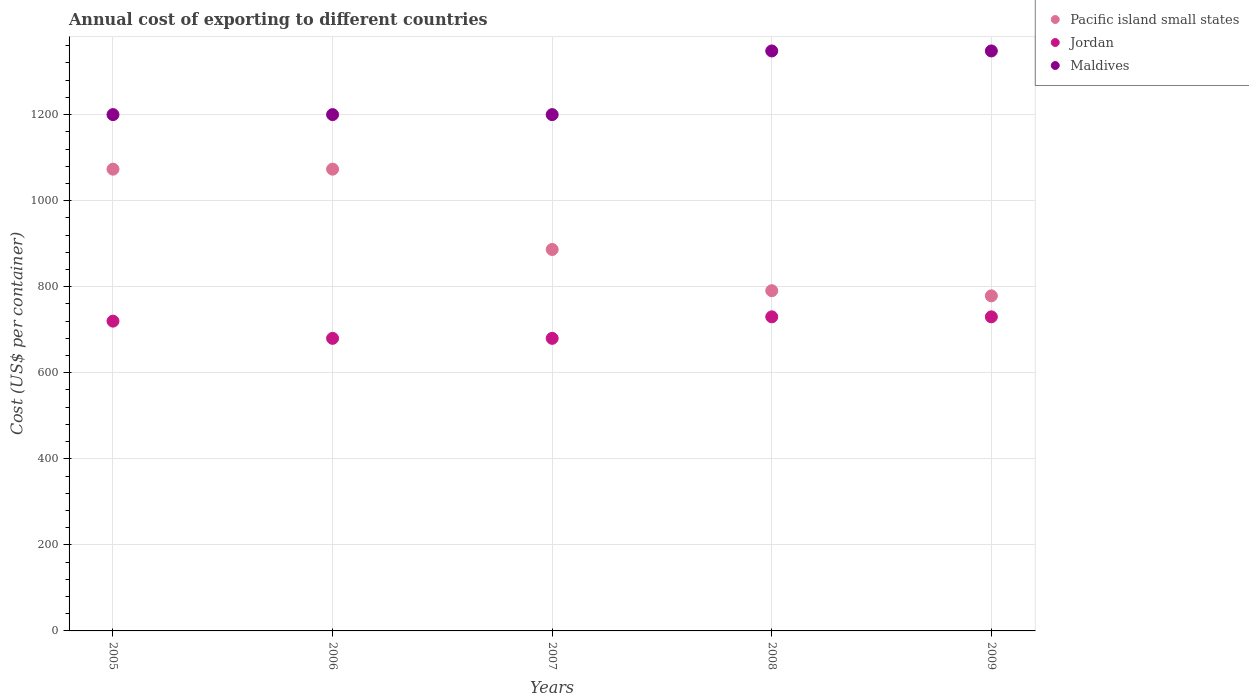What is the total annual cost of exporting in Pacific island small states in 2006?
Offer a terse response. 1073.22. Across all years, what is the maximum total annual cost of exporting in Maldives?
Offer a very short reply. 1348. Across all years, what is the minimum total annual cost of exporting in Pacific island small states?
Offer a terse response. 778.78. What is the total total annual cost of exporting in Maldives in the graph?
Provide a short and direct response. 6296. What is the difference between the total annual cost of exporting in Pacific island small states in 2007 and that in 2009?
Make the answer very short. 107.78. What is the difference between the total annual cost of exporting in Jordan in 2006 and the total annual cost of exporting in Pacific island small states in 2008?
Your answer should be compact. -110.78. What is the average total annual cost of exporting in Jordan per year?
Give a very brief answer. 708. In the year 2005, what is the difference between the total annual cost of exporting in Maldives and total annual cost of exporting in Pacific island small states?
Make the answer very short. 126.78. In how many years, is the total annual cost of exporting in Maldives greater than 880 US$?
Offer a terse response. 5. What is the ratio of the total annual cost of exporting in Maldives in 2005 to that in 2007?
Provide a succinct answer. 1. Is the total annual cost of exporting in Pacific island small states in 2005 less than that in 2007?
Offer a terse response. No. What is the difference between the highest and the second highest total annual cost of exporting in Pacific island small states?
Give a very brief answer. 0. What is the difference between the highest and the lowest total annual cost of exporting in Pacific island small states?
Your answer should be very brief. 294.44. Does the total annual cost of exporting in Maldives monotonically increase over the years?
Offer a terse response. No. Is the total annual cost of exporting in Jordan strictly less than the total annual cost of exporting in Maldives over the years?
Your response must be concise. Yes. How many dotlines are there?
Provide a succinct answer. 3. What is the difference between two consecutive major ticks on the Y-axis?
Provide a short and direct response. 200. Does the graph contain any zero values?
Provide a short and direct response. No. Does the graph contain grids?
Make the answer very short. Yes. Where does the legend appear in the graph?
Make the answer very short. Top right. How are the legend labels stacked?
Ensure brevity in your answer.  Vertical. What is the title of the graph?
Your answer should be very brief. Annual cost of exporting to different countries. Does "Ireland" appear as one of the legend labels in the graph?
Keep it short and to the point. No. What is the label or title of the Y-axis?
Offer a terse response. Cost (US$ per container). What is the Cost (US$ per container) of Pacific island small states in 2005?
Your response must be concise. 1073.22. What is the Cost (US$ per container) of Jordan in 2005?
Your answer should be very brief. 720. What is the Cost (US$ per container) of Maldives in 2005?
Provide a short and direct response. 1200. What is the Cost (US$ per container) of Pacific island small states in 2006?
Offer a terse response. 1073.22. What is the Cost (US$ per container) in Jordan in 2006?
Your answer should be very brief. 680. What is the Cost (US$ per container) of Maldives in 2006?
Keep it short and to the point. 1200. What is the Cost (US$ per container) in Pacific island small states in 2007?
Offer a terse response. 886.56. What is the Cost (US$ per container) of Jordan in 2007?
Offer a terse response. 680. What is the Cost (US$ per container) of Maldives in 2007?
Ensure brevity in your answer.  1200. What is the Cost (US$ per container) of Pacific island small states in 2008?
Offer a terse response. 790.78. What is the Cost (US$ per container) of Jordan in 2008?
Make the answer very short. 730. What is the Cost (US$ per container) of Maldives in 2008?
Give a very brief answer. 1348. What is the Cost (US$ per container) in Pacific island small states in 2009?
Provide a succinct answer. 778.78. What is the Cost (US$ per container) of Jordan in 2009?
Provide a succinct answer. 730. What is the Cost (US$ per container) of Maldives in 2009?
Provide a short and direct response. 1348. Across all years, what is the maximum Cost (US$ per container) of Pacific island small states?
Make the answer very short. 1073.22. Across all years, what is the maximum Cost (US$ per container) in Jordan?
Provide a succinct answer. 730. Across all years, what is the maximum Cost (US$ per container) of Maldives?
Ensure brevity in your answer.  1348. Across all years, what is the minimum Cost (US$ per container) of Pacific island small states?
Your answer should be very brief. 778.78. Across all years, what is the minimum Cost (US$ per container) of Jordan?
Offer a terse response. 680. Across all years, what is the minimum Cost (US$ per container) in Maldives?
Make the answer very short. 1200. What is the total Cost (US$ per container) of Pacific island small states in the graph?
Give a very brief answer. 4602.56. What is the total Cost (US$ per container) of Jordan in the graph?
Provide a succinct answer. 3540. What is the total Cost (US$ per container) of Maldives in the graph?
Offer a very short reply. 6296. What is the difference between the Cost (US$ per container) in Jordan in 2005 and that in 2006?
Your answer should be very brief. 40. What is the difference between the Cost (US$ per container) in Pacific island small states in 2005 and that in 2007?
Offer a terse response. 186.67. What is the difference between the Cost (US$ per container) of Maldives in 2005 and that in 2007?
Provide a short and direct response. 0. What is the difference between the Cost (US$ per container) of Pacific island small states in 2005 and that in 2008?
Your answer should be very brief. 282.44. What is the difference between the Cost (US$ per container) in Maldives in 2005 and that in 2008?
Provide a short and direct response. -148. What is the difference between the Cost (US$ per container) of Pacific island small states in 2005 and that in 2009?
Offer a very short reply. 294.44. What is the difference between the Cost (US$ per container) of Maldives in 2005 and that in 2009?
Give a very brief answer. -148. What is the difference between the Cost (US$ per container) of Pacific island small states in 2006 and that in 2007?
Make the answer very short. 186.67. What is the difference between the Cost (US$ per container) in Maldives in 2006 and that in 2007?
Provide a succinct answer. 0. What is the difference between the Cost (US$ per container) in Pacific island small states in 2006 and that in 2008?
Your answer should be very brief. 282.44. What is the difference between the Cost (US$ per container) in Maldives in 2006 and that in 2008?
Keep it short and to the point. -148. What is the difference between the Cost (US$ per container) of Pacific island small states in 2006 and that in 2009?
Ensure brevity in your answer.  294.44. What is the difference between the Cost (US$ per container) of Jordan in 2006 and that in 2009?
Your answer should be compact. -50. What is the difference between the Cost (US$ per container) in Maldives in 2006 and that in 2009?
Keep it short and to the point. -148. What is the difference between the Cost (US$ per container) of Pacific island small states in 2007 and that in 2008?
Your answer should be compact. 95.78. What is the difference between the Cost (US$ per container) of Jordan in 2007 and that in 2008?
Make the answer very short. -50. What is the difference between the Cost (US$ per container) in Maldives in 2007 and that in 2008?
Offer a very short reply. -148. What is the difference between the Cost (US$ per container) of Pacific island small states in 2007 and that in 2009?
Ensure brevity in your answer.  107.78. What is the difference between the Cost (US$ per container) in Jordan in 2007 and that in 2009?
Provide a short and direct response. -50. What is the difference between the Cost (US$ per container) of Maldives in 2007 and that in 2009?
Provide a succinct answer. -148. What is the difference between the Cost (US$ per container) in Pacific island small states in 2008 and that in 2009?
Your answer should be very brief. 12. What is the difference between the Cost (US$ per container) of Jordan in 2008 and that in 2009?
Provide a succinct answer. 0. What is the difference between the Cost (US$ per container) in Pacific island small states in 2005 and the Cost (US$ per container) in Jordan in 2006?
Give a very brief answer. 393.22. What is the difference between the Cost (US$ per container) of Pacific island small states in 2005 and the Cost (US$ per container) of Maldives in 2006?
Your response must be concise. -126.78. What is the difference between the Cost (US$ per container) of Jordan in 2005 and the Cost (US$ per container) of Maldives in 2006?
Give a very brief answer. -480. What is the difference between the Cost (US$ per container) of Pacific island small states in 2005 and the Cost (US$ per container) of Jordan in 2007?
Provide a succinct answer. 393.22. What is the difference between the Cost (US$ per container) in Pacific island small states in 2005 and the Cost (US$ per container) in Maldives in 2007?
Provide a short and direct response. -126.78. What is the difference between the Cost (US$ per container) of Jordan in 2005 and the Cost (US$ per container) of Maldives in 2007?
Ensure brevity in your answer.  -480. What is the difference between the Cost (US$ per container) in Pacific island small states in 2005 and the Cost (US$ per container) in Jordan in 2008?
Offer a terse response. 343.22. What is the difference between the Cost (US$ per container) in Pacific island small states in 2005 and the Cost (US$ per container) in Maldives in 2008?
Provide a short and direct response. -274.78. What is the difference between the Cost (US$ per container) in Jordan in 2005 and the Cost (US$ per container) in Maldives in 2008?
Offer a terse response. -628. What is the difference between the Cost (US$ per container) of Pacific island small states in 2005 and the Cost (US$ per container) of Jordan in 2009?
Your answer should be very brief. 343.22. What is the difference between the Cost (US$ per container) in Pacific island small states in 2005 and the Cost (US$ per container) in Maldives in 2009?
Ensure brevity in your answer.  -274.78. What is the difference between the Cost (US$ per container) of Jordan in 2005 and the Cost (US$ per container) of Maldives in 2009?
Your response must be concise. -628. What is the difference between the Cost (US$ per container) of Pacific island small states in 2006 and the Cost (US$ per container) of Jordan in 2007?
Offer a very short reply. 393.22. What is the difference between the Cost (US$ per container) of Pacific island small states in 2006 and the Cost (US$ per container) of Maldives in 2007?
Keep it short and to the point. -126.78. What is the difference between the Cost (US$ per container) of Jordan in 2006 and the Cost (US$ per container) of Maldives in 2007?
Provide a succinct answer. -520. What is the difference between the Cost (US$ per container) of Pacific island small states in 2006 and the Cost (US$ per container) of Jordan in 2008?
Your answer should be very brief. 343.22. What is the difference between the Cost (US$ per container) in Pacific island small states in 2006 and the Cost (US$ per container) in Maldives in 2008?
Keep it short and to the point. -274.78. What is the difference between the Cost (US$ per container) in Jordan in 2006 and the Cost (US$ per container) in Maldives in 2008?
Your response must be concise. -668. What is the difference between the Cost (US$ per container) in Pacific island small states in 2006 and the Cost (US$ per container) in Jordan in 2009?
Give a very brief answer. 343.22. What is the difference between the Cost (US$ per container) in Pacific island small states in 2006 and the Cost (US$ per container) in Maldives in 2009?
Give a very brief answer. -274.78. What is the difference between the Cost (US$ per container) of Jordan in 2006 and the Cost (US$ per container) of Maldives in 2009?
Provide a short and direct response. -668. What is the difference between the Cost (US$ per container) of Pacific island small states in 2007 and the Cost (US$ per container) of Jordan in 2008?
Make the answer very short. 156.56. What is the difference between the Cost (US$ per container) of Pacific island small states in 2007 and the Cost (US$ per container) of Maldives in 2008?
Provide a short and direct response. -461.44. What is the difference between the Cost (US$ per container) in Jordan in 2007 and the Cost (US$ per container) in Maldives in 2008?
Your response must be concise. -668. What is the difference between the Cost (US$ per container) of Pacific island small states in 2007 and the Cost (US$ per container) of Jordan in 2009?
Provide a succinct answer. 156.56. What is the difference between the Cost (US$ per container) of Pacific island small states in 2007 and the Cost (US$ per container) of Maldives in 2009?
Provide a short and direct response. -461.44. What is the difference between the Cost (US$ per container) in Jordan in 2007 and the Cost (US$ per container) in Maldives in 2009?
Your answer should be very brief. -668. What is the difference between the Cost (US$ per container) of Pacific island small states in 2008 and the Cost (US$ per container) of Jordan in 2009?
Provide a succinct answer. 60.78. What is the difference between the Cost (US$ per container) in Pacific island small states in 2008 and the Cost (US$ per container) in Maldives in 2009?
Ensure brevity in your answer.  -557.22. What is the difference between the Cost (US$ per container) of Jordan in 2008 and the Cost (US$ per container) of Maldives in 2009?
Keep it short and to the point. -618. What is the average Cost (US$ per container) of Pacific island small states per year?
Your response must be concise. 920.51. What is the average Cost (US$ per container) in Jordan per year?
Ensure brevity in your answer.  708. What is the average Cost (US$ per container) of Maldives per year?
Provide a succinct answer. 1259.2. In the year 2005, what is the difference between the Cost (US$ per container) of Pacific island small states and Cost (US$ per container) of Jordan?
Give a very brief answer. 353.22. In the year 2005, what is the difference between the Cost (US$ per container) of Pacific island small states and Cost (US$ per container) of Maldives?
Offer a very short reply. -126.78. In the year 2005, what is the difference between the Cost (US$ per container) of Jordan and Cost (US$ per container) of Maldives?
Give a very brief answer. -480. In the year 2006, what is the difference between the Cost (US$ per container) of Pacific island small states and Cost (US$ per container) of Jordan?
Give a very brief answer. 393.22. In the year 2006, what is the difference between the Cost (US$ per container) of Pacific island small states and Cost (US$ per container) of Maldives?
Ensure brevity in your answer.  -126.78. In the year 2006, what is the difference between the Cost (US$ per container) in Jordan and Cost (US$ per container) in Maldives?
Keep it short and to the point. -520. In the year 2007, what is the difference between the Cost (US$ per container) in Pacific island small states and Cost (US$ per container) in Jordan?
Offer a very short reply. 206.56. In the year 2007, what is the difference between the Cost (US$ per container) in Pacific island small states and Cost (US$ per container) in Maldives?
Provide a succinct answer. -313.44. In the year 2007, what is the difference between the Cost (US$ per container) of Jordan and Cost (US$ per container) of Maldives?
Offer a terse response. -520. In the year 2008, what is the difference between the Cost (US$ per container) of Pacific island small states and Cost (US$ per container) of Jordan?
Your response must be concise. 60.78. In the year 2008, what is the difference between the Cost (US$ per container) of Pacific island small states and Cost (US$ per container) of Maldives?
Your response must be concise. -557.22. In the year 2008, what is the difference between the Cost (US$ per container) in Jordan and Cost (US$ per container) in Maldives?
Provide a short and direct response. -618. In the year 2009, what is the difference between the Cost (US$ per container) of Pacific island small states and Cost (US$ per container) of Jordan?
Ensure brevity in your answer.  48.78. In the year 2009, what is the difference between the Cost (US$ per container) in Pacific island small states and Cost (US$ per container) in Maldives?
Your answer should be compact. -569.22. In the year 2009, what is the difference between the Cost (US$ per container) of Jordan and Cost (US$ per container) of Maldives?
Your answer should be very brief. -618. What is the ratio of the Cost (US$ per container) of Jordan in 2005 to that in 2006?
Make the answer very short. 1.06. What is the ratio of the Cost (US$ per container) of Pacific island small states in 2005 to that in 2007?
Provide a short and direct response. 1.21. What is the ratio of the Cost (US$ per container) of Jordan in 2005 to that in 2007?
Provide a succinct answer. 1.06. What is the ratio of the Cost (US$ per container) in Pacific island small states in 2005 to that in 2008?
Ensure brevity in your answer.  1.36. What is the ratio of the Cost (US$ per container) in Jordan in 2005 to that in 2008?
Make the answer very short. 0.99. What is the ratio of the Cost (US$ per container) in Maldives in 2005 to that in 2008?
Your response must be concise. 0.89. What is the ratio of the Cost (US$ per container) in Pacific island small states in 2005 to that in 2009?
Give a very brief answer. 1.38. What is the ratio of the Cost (US$ per container) in Jordan in 2005 to that in 2009?
Ensure brevity in your answer.  0.99. What is the ratio of the Cost (US$ per container) in Maldives in 2005 to that in 2009?
Your answer should be very brief. 0.89. What is the ratio of the Cost (US$ per container) in Pacific island small states in 2006 to that in 2007?
Give a very brief answer. 1.21. What is the ratio of the Cost (US$ per container) of Jordan in 2006 to that in 2007?
Provide a short and direct response. 1. What is the ratio of the Cost (US$ per container) of Pacific island small states in 2006 to that in 2008?
Your response must be concise. 1.36. What is the ratio of the Cost (US$ per container) in Jordan in 2006 to that in 2008?
Give a very brief answer. 0.93. What is the ratio of the Cost (US$ per container) in Maldives in 2006 to that in 2008?
Offer a very short reply. 0.89. What is the ratio of the Cost (US$ per container) in Pacific island small states in 2006 to that in 2009?
Offer a terse response. 1.38. What is the ratio of the Cost (US$ per container) of Jordan in 2006 to that in 2009?
Offer a terse response. 0.93. What is the ratio of the Cost (US$ per container) of Maldives in 2006 to that in 2009?
Your answer should be compact. 0.89. What is the ratio of the Cost (US$ per container) of Pacific island small states in 2007 to that in 2008?
Ensure brevity in your answer.  1.12. What is the ratio of the Cost (US$ per container) in Jordan in 2007 to that in 2008?
Your response must be concise. 0.93. What is the ratio of the Cost (US$ per container) in Maldives in 2007 to that in 2008?
Make the answer very short. 0.89. What is the ratio of the Cost (US$ per container) of Pacific island small states in 2007 to that in 2009?
Ensure brevity in your answer.  1.14. What is the ratio of the Cost (US$ per container) of Jordan in 2007 to that in 2009?
Your answer should be compact. 0.93. What is the ratio of the Cost (US$ per container) of Maldives in 2007 to that in 2009?
Keep it short and to the point. 0.89. What is the ratio of the Cost (US$ per container) in Pacific island small states in 2008 to that in 2009?
Make the answer very short. 1.02. What is the ratio of the Cost (US$ per container) of Maldives in 2008 to that in 2009?
Provide a short and direct response. 1. What is the difference between the highest and the second highest Cost (US$ per container) of Maldives?
Your response must be concise. 0. What is the difference between the highest and the lowest Cost (US$ per container) of Pacific island small states?
Give a very brief answer. 294.44. What is the difference between the highest and the lowest Cost (US$ per container) in Maldives?
Keep it short and to the point. 148. 